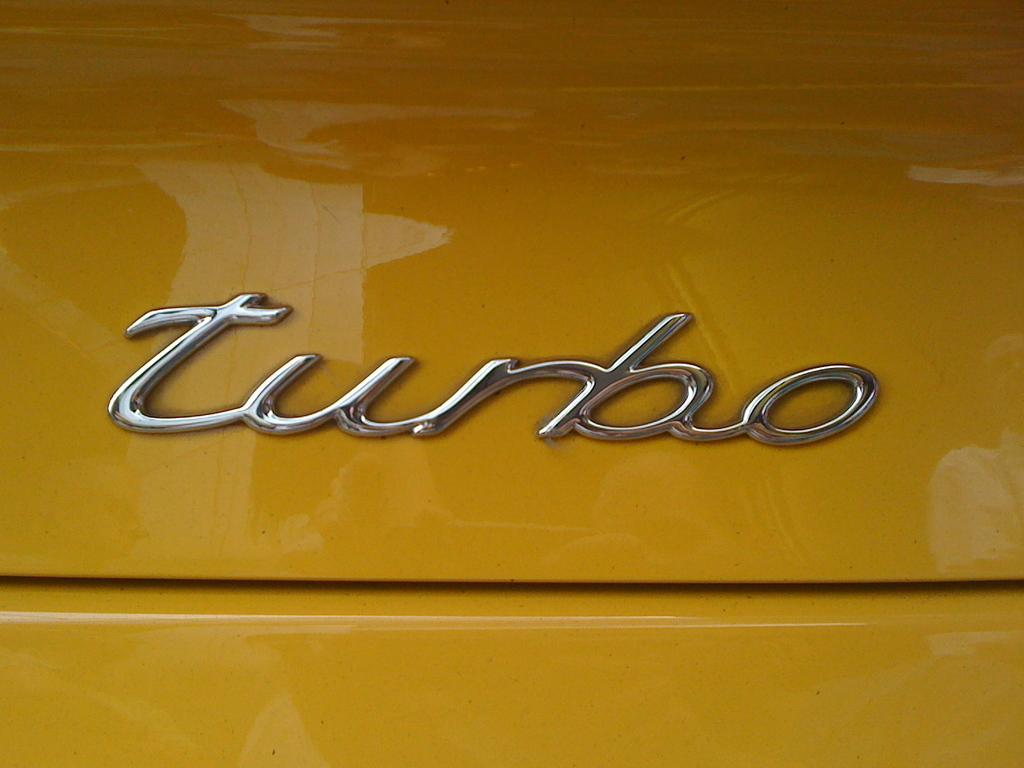What can be seen written on the board in the image? There is a name on the board in the image. What color is the background of the image? The background of the image appears to be yellow in color. How many bees can be seen flying around the name on the board in the image? There are no bees present in the image. What type of fowl is sitting on the board in the image? There is no fowl present in the image. 